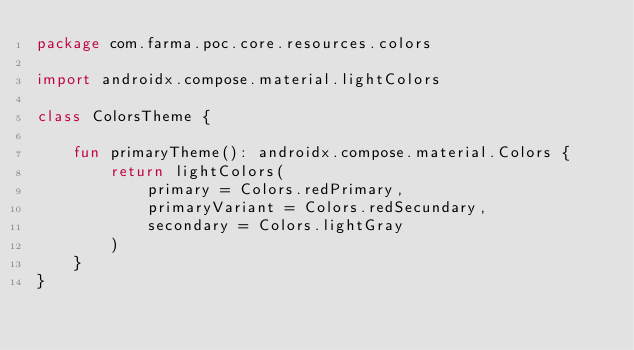<code> <loc_0><loc_0><loc_500><loc_500><_Kotlin_>package com.farma.poc.core.resources.colors

import androidx.compose.material.lightColors

class ColorsTheme {

    fun primaryTheme(): androidx.compose.material.Colors {
        return lightColors(
            primary = Colors.redPrimary,
            primaryVariant = Colors.redSecundary,
            secondary = Colors.lightGray
        )
    }
}</code> 